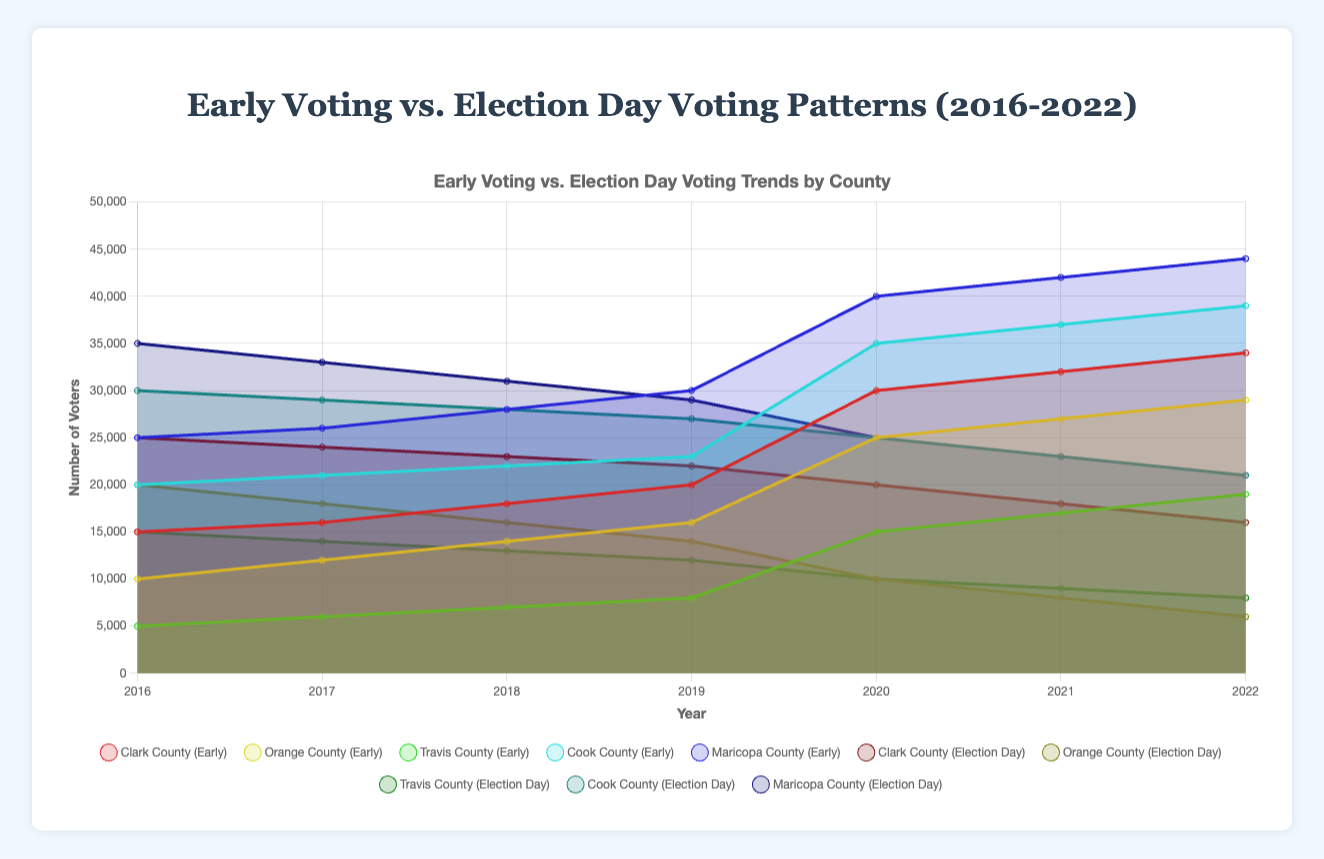What is the title of the chart? The title of the chart is displayed at the top and reads "Early Voting vs. Election Day Voting Patterns (2016-2022)".
Answer: Early Voting vs. Election Day Voting Patterns (2016-2022) Which county had the highest number of early voters in 2022? By looking at the 2022 datapoints for early voting, Maricopa County had the highest number of early voters with 44,000.
Answer: Maricopa County Which county shows a decrease in Election Day voting from 2016 to 2022? By examining the Election Day voting data from 2016 to 2022, all five counties (Clark, Orange, Travis, Cook, Maricopa) show a decrease.
Answer: All five counties In which year did Clark County have an equal number of voters for both Early Voting and Election Day Voting? Clark County had 20,000 voters for both Early Voting and Election Day Voting in the year 2020.
Answer: 2020 How many total voters did Travis County have in 2020 combining both early and election day votes? In 2020, Travis County had 15,000 early voters and 10,000 election day voters. Adding them together gives a total of 25,000 voters.
Answer: 25,000 Which county had the largest difference between early voting and election day voting in 2021, and what was the difference? By observing the 2021 data, Orange County had a 19,000 difference (27,000 early voters minus 8,000 election day voters).
Answer: Orange County, 19,000 Compare the trend of early voting in Cook County to that of Travis County from 2016 to 2022. Cook County's early voting shows a steady increase each year from 20,000 to 39,000. Travis County also shows an increasing trend from 5,000 to 19,000. Both counties show an upward trend.
Answer: Both counties show an upward trend What is the general trend observed in Early Voting from 2016 to 2022 across all counties? The early voting numbers in all counties have generally increased from 2016 to 2022.
Answer: Increasing trend In which year did Maricopa County have the most significant drop in Election Day voting compared to its previous year? Maricopa County had the most significant drop in Election Day voting from 2016 (35,000) to 2017 (33,000), a decrease of 2,000.
Answer: From 2016 to 2017 How does the ratio of early voting to election day voting change in Clark County from 2016 to 2022? In 2016, the ratio was 15,000 early to 25,000 election day, which is 3:5. By 2022, the ratio changed to 34,000 early to 16,000 election day, which is more than 2:1. The ratio has flipped significantly in favor of early voting.
Answer: Flipped significantly in favor of early voting 